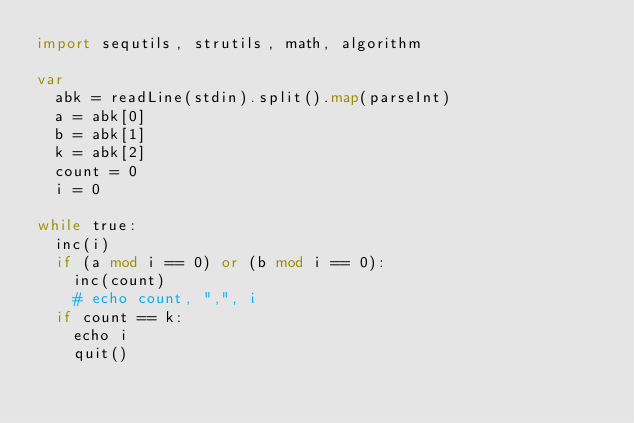Convert code to text. <code><loc_0><loc_0><loc_500><loc_500><_Nim_>import sequtils, strutils, math, algorithm

var
  abk = readLine(stdin).split().map(parseInt)
  a = abk[0]
  b = abk[1]
  k = abk[2]
  count = 0
  i = 0

while true:
  inc(i)
  if (a mod i == 0) or (b mod i == 0):
    inc(count)
    # echo count, ",", i
  if count == k:
    echo i
    quit()</code> 